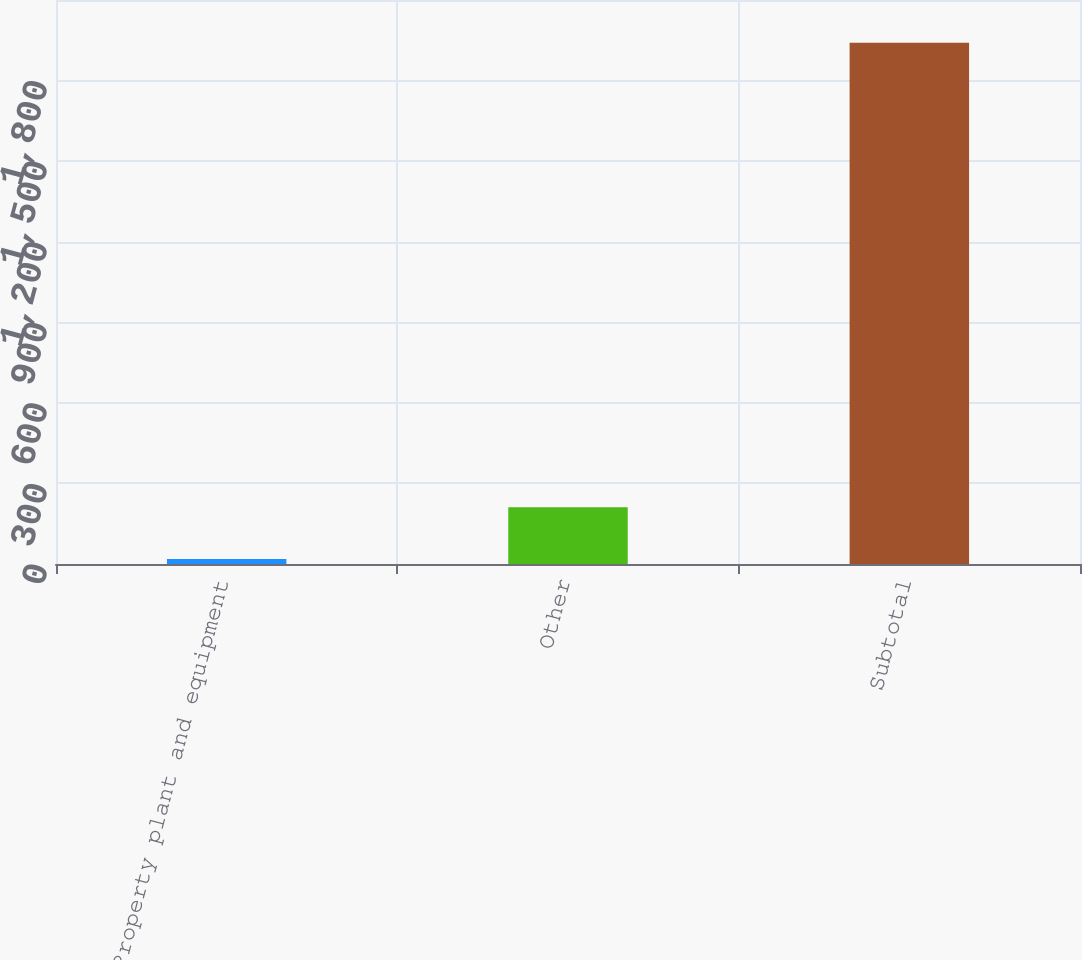Convert chart to OTSL. <chart><loc_0><loc_0><loc_500><loc_500><bar_chart><fcel>Property plant and equipment<fcel>Other<fcel>Subtotal<nl><fcel>19<fcel>211.2<fcel>1941<nl></chart> 